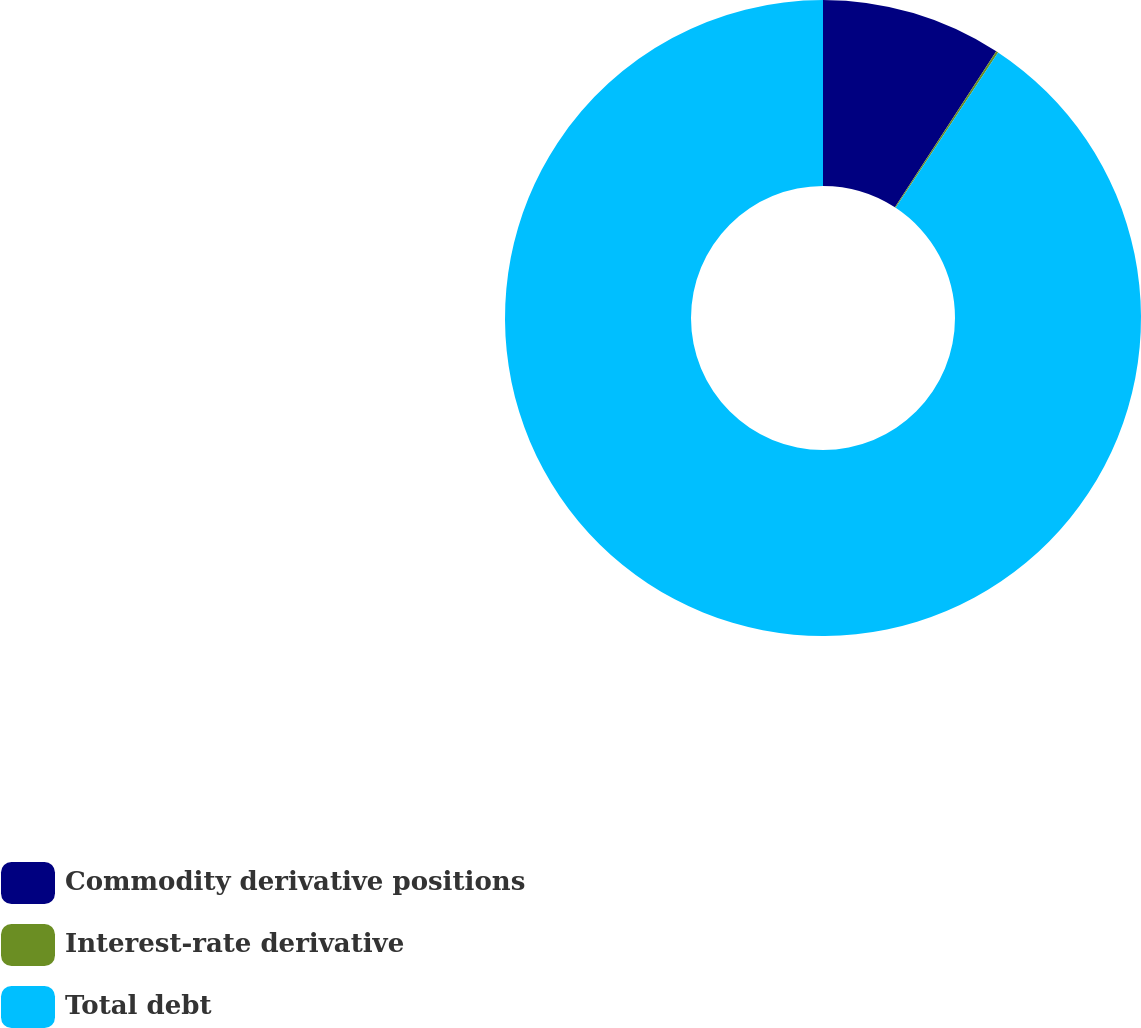Convert chart. <chart><loc_0><loc_0><loc_500><loc_500><pie_chart><fcel>Commodity derivative positions<fcel>Interest-rate derivative<fcel>Total debt<nl><fcel>9.17%<fcel>0.11%<fcel>90.71%<nl></chart> 